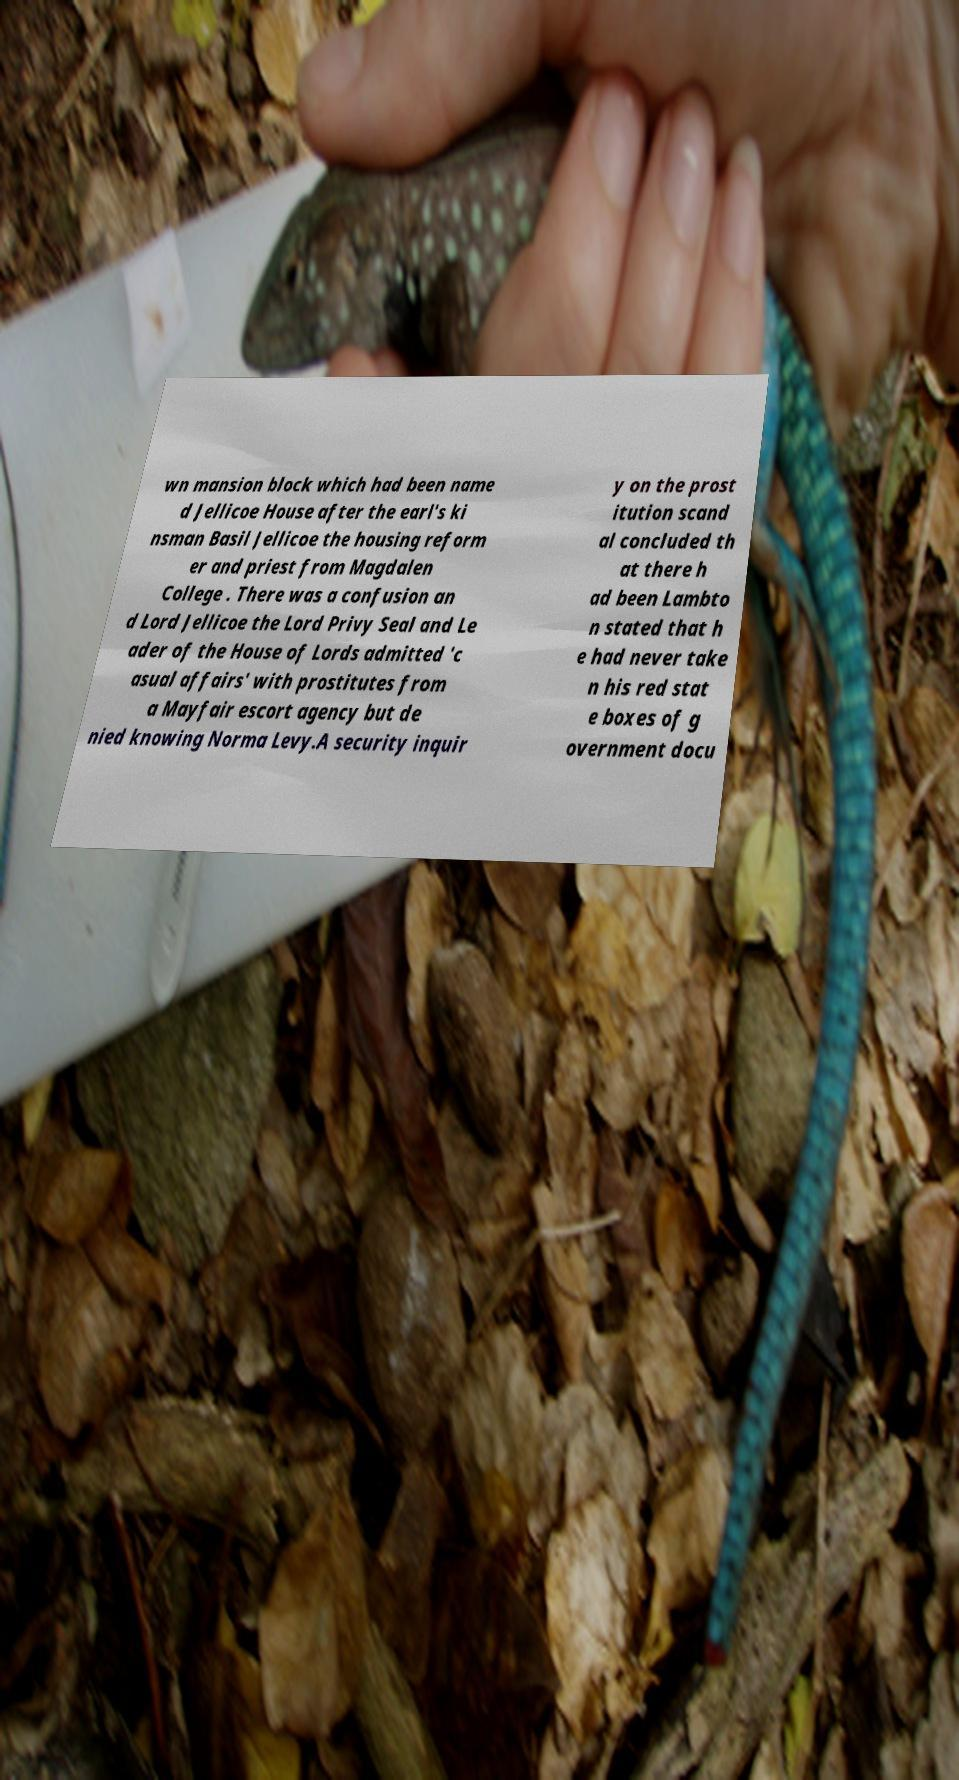Please identify and transcribe the text found in this image. wn mansion block which had been name d Jellicoe House after the earl's ki nsman Basil Jellicoe the housing reform er and priest from Magdalen College . There was a confusion an d Lord Jellicoe the Lord Privy Seal and Le ader of the House of Lords admitted 'c asual affairs' with prostitutes from a Mayfair escort agency but de nied knowing Norma Levy.A security inquir y on the prost itution scand al concluded th at there h ad been Lambto n stated that h e had never take n his red stat e boxes of g overnment docu 